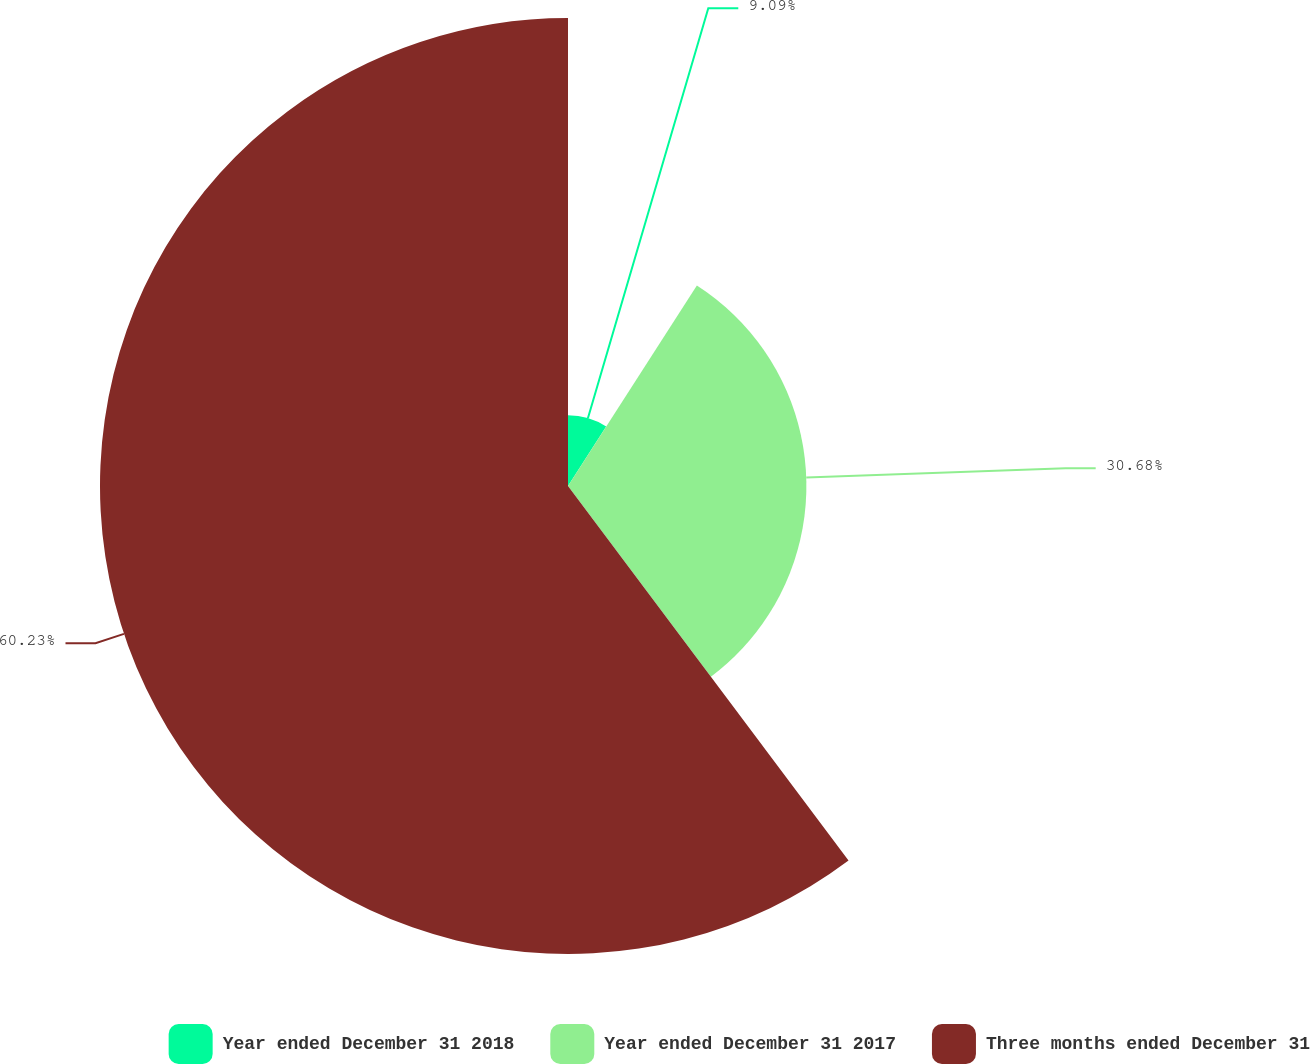Convert chart to OTSL. <chart><loc_0><loc_0><loc_500><loc_500><pie_chart><fcel>Year ended December 31 2018<fcel>Year ended December 31 2017<fcel>Three months ended December 31<nl><fcel>9.09%<fcel>30.68%<fcel>60.23%<nl></chart> 